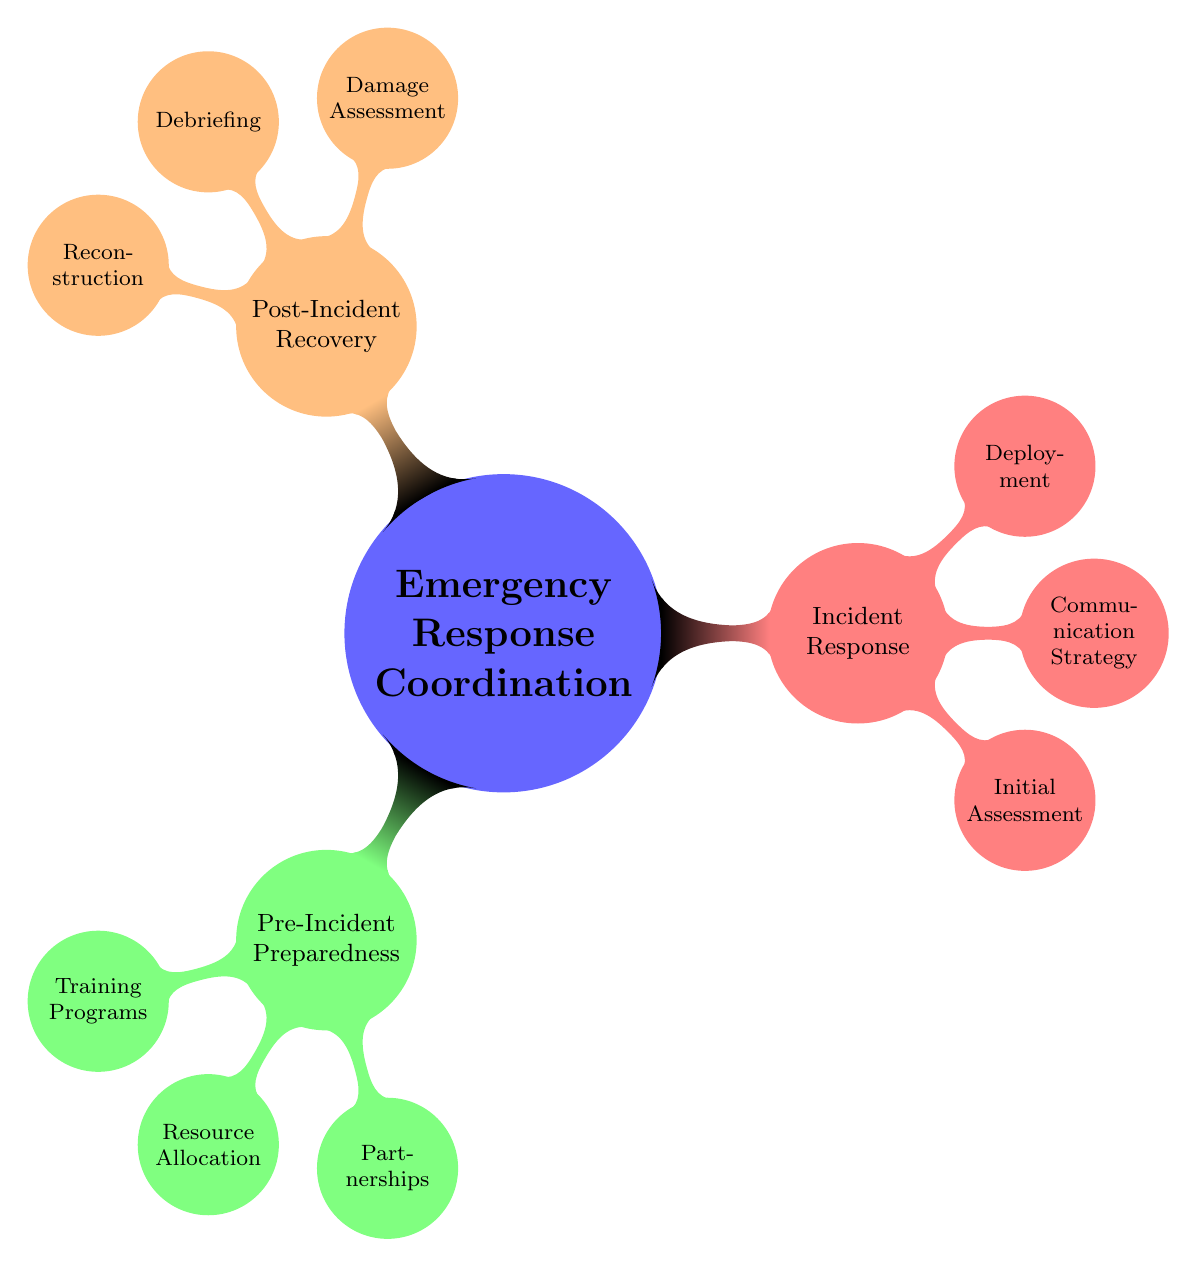What are the three main categories of emergency response coordination? The diagram shows three main categories, which are displayed as the first-level nodes branching from the central node labeled "Emergency Response Coordination." The three categories are "Pre-Incident Preparedness," "Incident Response," and "Post-Incident Recovery."
Answer: Pre-Incident Preparedness, Incident Response, Post-Incident Recovery How many subcategories does "Incident Response" have? By examining the "Incident Response" node, there are three subcategories listed underneath it: "Initial Assessment," "Communication Strategy," and "Deployment." Counting these gives a total of three subcategories.
Answer: 3 What training program is included in "Pre-Incident Preparedness"? This answer can be found by looking under the "Training Programs" node, which is a subcategory of "Pre-Incident Preparedness." The diagram lists three specific training programs: "First Aid Certification," "Fire Safety Training," and "Hazmat Handling," so any of these would be a correct answer.
Answer: First Aid Certification Which node connects "Reconstruction" directly to "Post-Incident Recovery"? To find this, we look at the "Reconstruction" subcategory, which is under the "Post-Incident Recovery" section. It is a direct child node, meaning there are no other nodes between them. Therefore, "Reconstruction" connects directly to "Post-Incident Recovery."
Answer: Post-Incident Recovery What is the relationship between "Partnerships" and "Resource Allocation"? Both "Partnerships" and "Resource Allocation" are children nodes of "Pre-Incident Preparedness," meaning that they are part of the same parent category. This indicates that both elements are considered essential components under the overarching theme of preparedness before incidents occur.
Answer: They are siblings under Pre-Incident Preparedness 